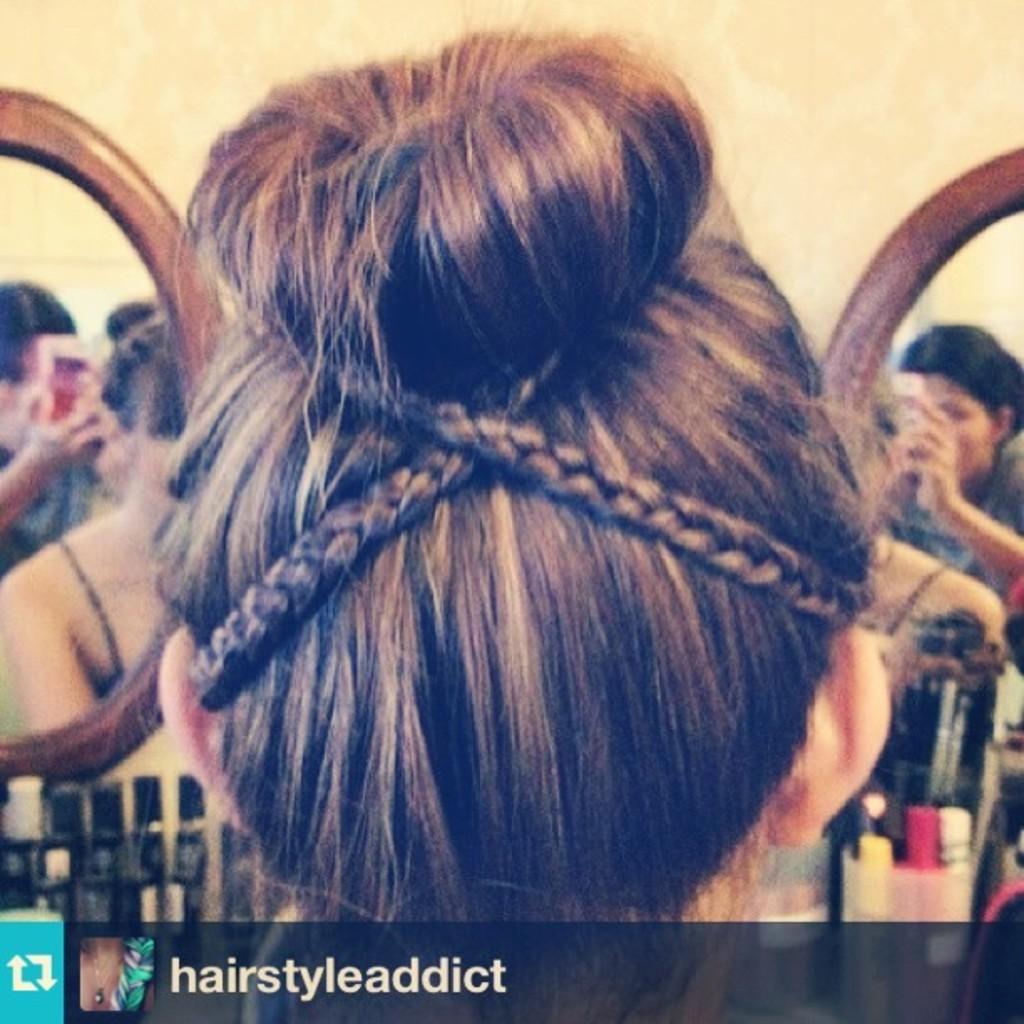How would you summarize this image in a sentence or two? In this image, we can see a person hairstyle. In the background of the image, we can see some persons. 